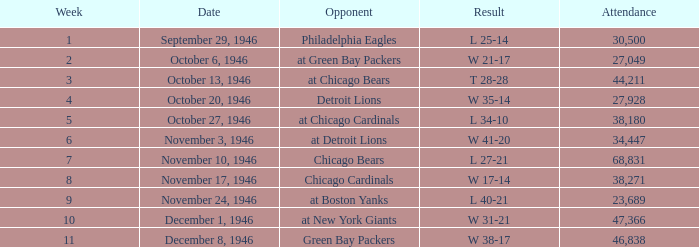What is the combined attendance of all games that had a result of w 35-14? 27928.0. 